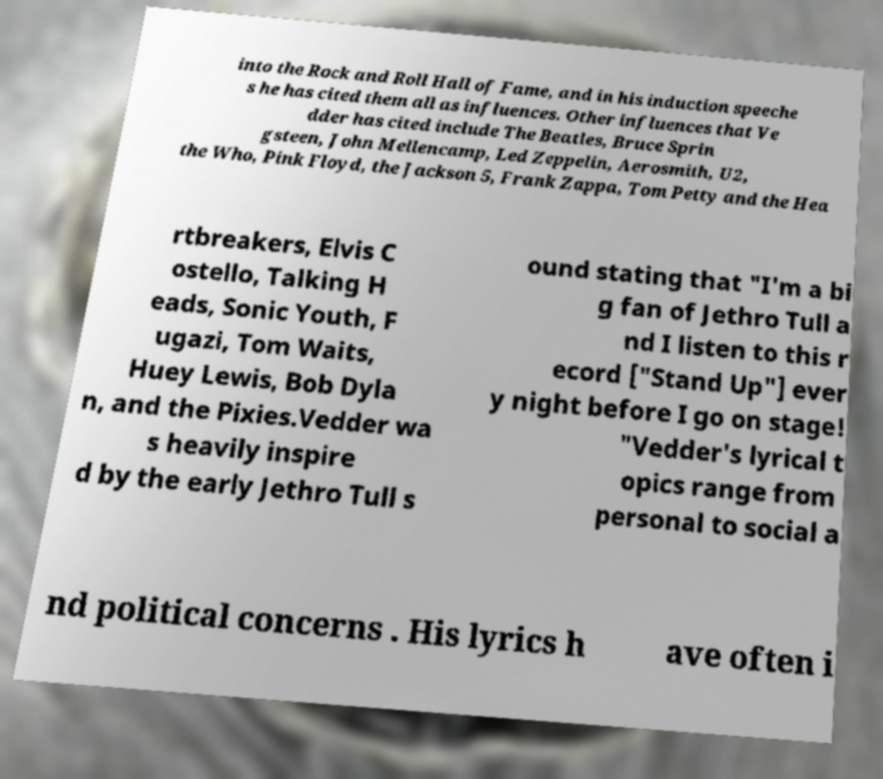Could you assist in decoding the text presented in this image and type it out clearly? into the Rock and Roll Hall of Fame, and in his induction speeche s he has cited them all as influences. Other influences that Ve dder has cited include The Beatles, Bruce Sprin gsteen, John Mellencamp, Led Zeppelin, Aerosmith, U2, the Who, Pink Floyd, the Jackson 5, Frank Zappa, Tom Petty and the Hea rtbreakers, Elvis C ostello, Talking H eads, Sonic Youth, F ugazi, Tom Waits, Huey Lewis, Bob Dyla n, and the Pixies.Vedder wa s heavily inspire d by the early Jethro Tull s ound stating that "I'm a bi g fan of Jethro Tull a nd I listen to this r ecord ["Stand Up"] ever y night before I go on stage! "Vedder's lyrical t opics range from personal to social a nd political concerns . His lyrics h ave often i 